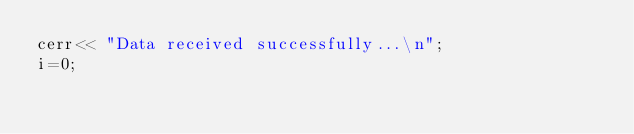<code> <loc_0><loc_0><loc_500><loc_500><_ObjectiveC_>cerr<< "Data received successfully...\n";
i=0;
</code> 